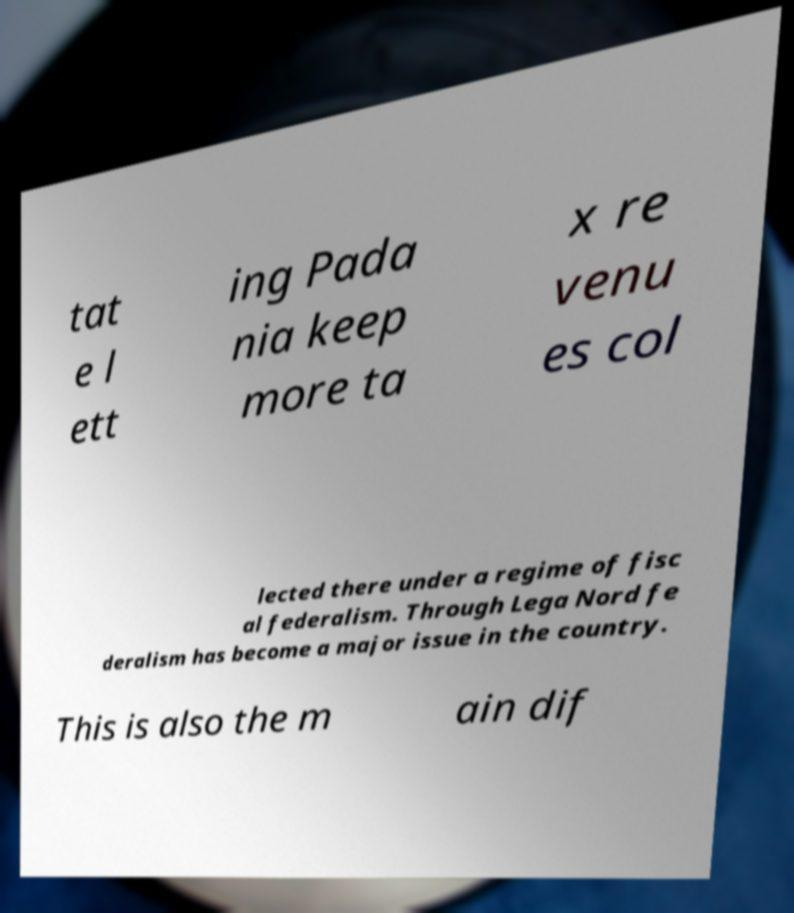There's text embedded in this image that I need extracted. Can you transcribe it verbatim? tat e l ett ing Pada nia keep more ta x re venu es col lected there under a regime of fisc al federalism. Through Lega Nord fe deralism has become a major issue in the country. This is also the m ain dif 